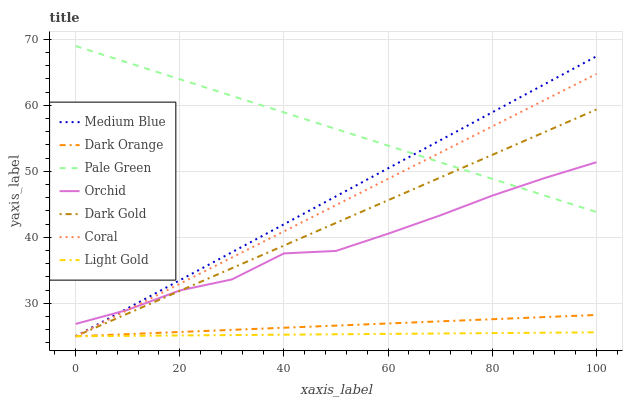Does Light Gold have the minimum area under the curve?
Answer yes or no. Yes. Does Pale Green have the maximum area under the curve?
Answer yes or no. Yes. Does Dark Gold have the minimum area under the curve?
Answer yes or no. No. Does Dark Gold have the maximum area under the curve?
Answer yes or no. No. Is Dark Orange the smoothest?
Answer yes or no. Yes. Is Orchid the roughest?
Answer yes or no. Yes. Is Dark Gold the smoothest?
Answer yes or no. No. Is Dark Gold the roughest?
Answer yes or no. No. Does Dark Orange have the lowest value?
Answer yes or no. Yes. Does Pale Green have the lowest value?
Answer yes or no. No. Does Pale Green have the highest value?
Answer yes or no. Yes. Does Dark Gold have the highest value?
Answer yes or no. No. Is Light Gold less than Orchid?
Answer yes or no. Yes. Is Pale Green greater than Light Gold?
Answer yes or no. Yes. Does Pale Green intersect Orchid?
Answer yes or no. Yes. Is Pale Green less than Orchid?
Answer yes or no. No. Is Pale Green greater than Orchid?
Answer yes or no. No. Does Light Gold intersect Orchid?
Answer yes or no. No. 